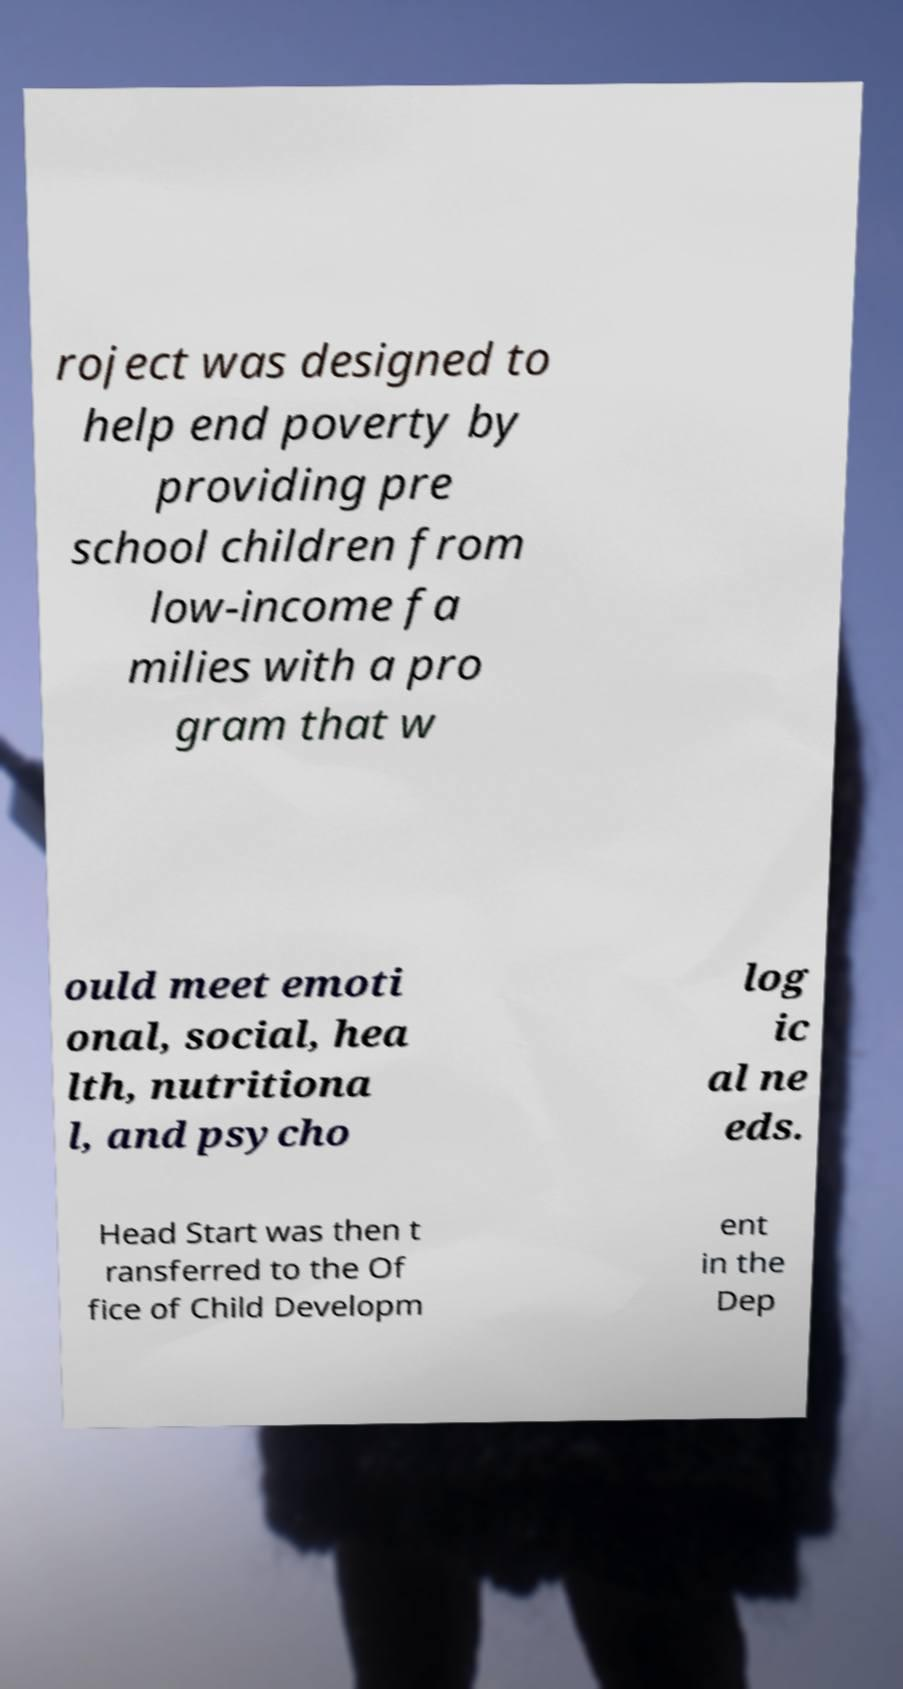What messages or text are displayed in this image? I need them in a readable, typed format. roject was designed to help end poverty by providing pre school children from low-income fa milies with a pro gram that w ould meet emoti onal, social, hea lth, nutritiona l, and psycho log ic al ne eds. Head Start was then t ransferred to the Of fice of Child Developm ent in the Dep 